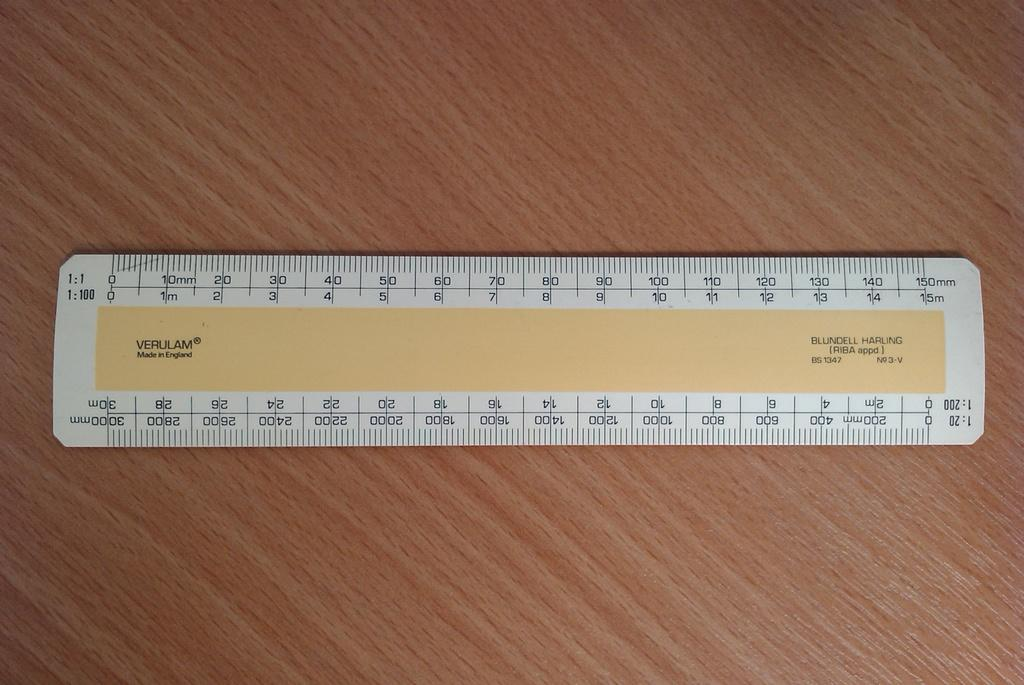<image>
Present a compact description of the photo's key features. A Verulam ruler on a wooden table says made in England. 